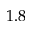Convert formula to latex. <formula><loc_0><loc_0><loc_500><loc_500>1 . 8</formula> 